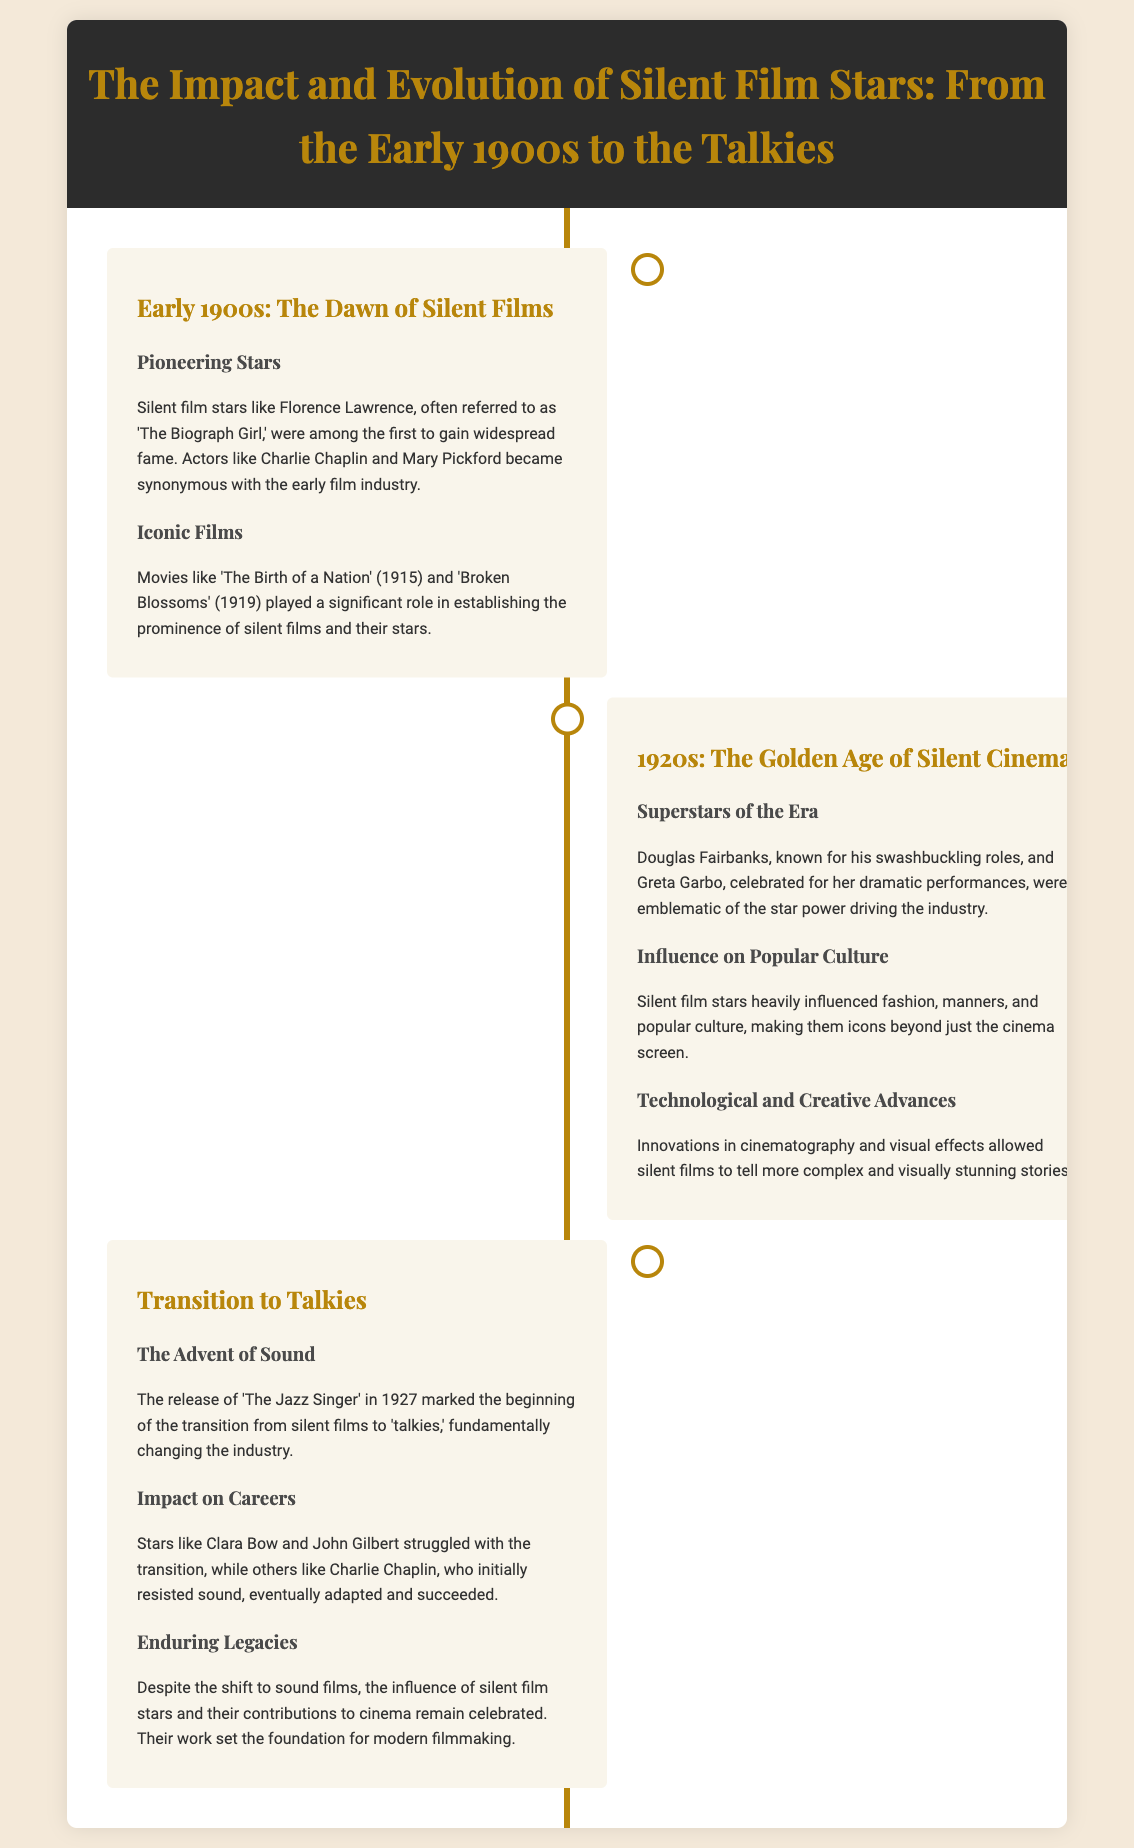what was the first widely recognized silent film star? Florence Lawrence was often referred to as 'The Biograph Girl,' gaining early fame in silent films.
Answer: Florence Lawrence which film is recognized as the beginning of the transition to talkies? 'The Jazz Singer' released in 1927 marked the start of the transition from silent films to 'talkies.'
Answer: The Jazz Singer who were two iconic silent film stars of the 1920s? Douglas Fairbanks and Greta Garbo were superstars emblematic of the silent film era.
Answer: Douglas Fairbanks, Greta Garbo what significant impact did silent film stars have on popular culture? They influenced fashion, manners, and became icons beyond just the cinema screen.
Answer: Fashion and manners which film was released in 1915 that played a significant role in establishing silent films? 'The Birth of a Nation' released in 1915 established the prominence of silent films.
Answer: The Birth of a Nation how did Clara Bow's career change with the advent of sound films? Clara Bow struggled with the transition to talkies, indicating difficulties for some silent film stars.
Answer: Struggled during which decade did silent cinema reach its golden age? The 1920s are referred to as the Golden Age of Silent Cinema.
Answer: 1920s what innovative developments helped tell more complex stories in silent films? Innovations in cinematography and visual effects allowed for more complex storytelling.
Answer: Cinematography and visual effects 